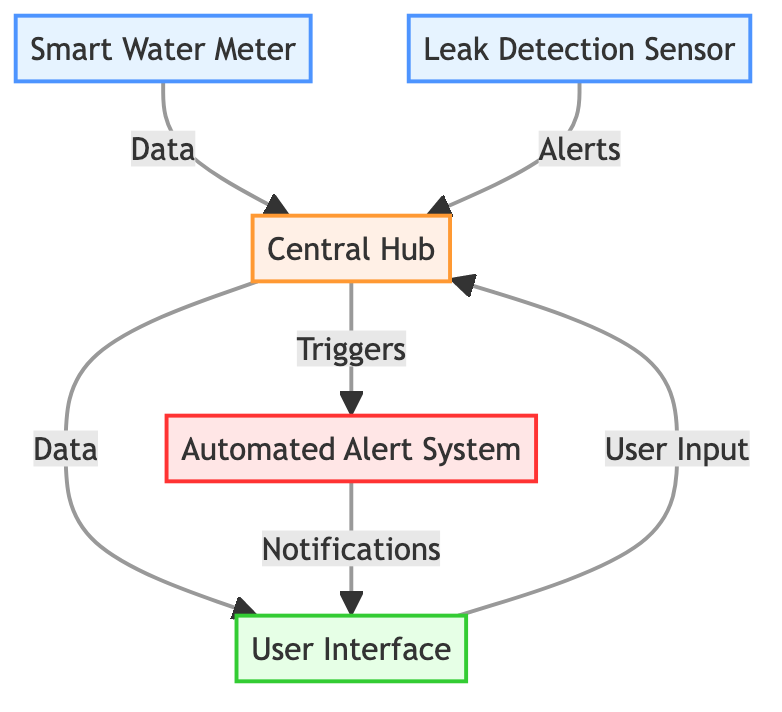What is the type of the Smart Water Meter? The Smart Water Meter is categorized as a "sensor" in the diagram. This can be seen in its designation, which specifically identifies its role and function within the system.
Answer: sensor How many components are connected to the Central Hub? The Central Hub has four connections, including the Smart Water Meter, Leak Detection Sensor, User Interface, and Automated Alert System. Counting these connections provides the total component number linked to the Central Hub.
Answer: four What type of connection does the Leak Detection Sensor have to the Central Hub? The connection from the Leak Detection Sensor to the Central Hub is labeled as "Alerts," indicating that it sends alert notifications related to leak detections to the Central Hub.
Answer: Alerts What type of system is the User Interface? The User Interface is specified as a "display/control" type in the diagram. This information is explicitly stated under its description within the layout, highlighting its function in the system.
Answer: display/control How does the Automated Alert System communicate with the User Interface? The Automated Alert System sends "Notifications" to the User Interface, according to the diagram's connections. This suggests that alerts and notifications from the system are conveyed to the User Interface for user awareness.
Answer: Notifications What does the Smart Water Meter send to the Central Hub? The Smart Water Meter sends "Data" to the Central Hub. This is clearly indicated on the connection line from the Smart Water Meter to the Central Hub in the diagram, defining the type of information transmitted.
Answer: Data What component is responsible for processing the information gathered from the sensors? The Central Hub is responsible for processing the information, as indicated by its description in the diagram, which states it receives data from sensors and meters, processes it, and communicates with the User Interface.
Answer: Central Hub What action does the Central Hub trigger downstream? The Central Hub triggers the "Automated Alert System" as one of its outputs, which is directly shown in the diagram's flow, indicating that upon processing data, it can initiate alerts for users.
Answer: Triggers 